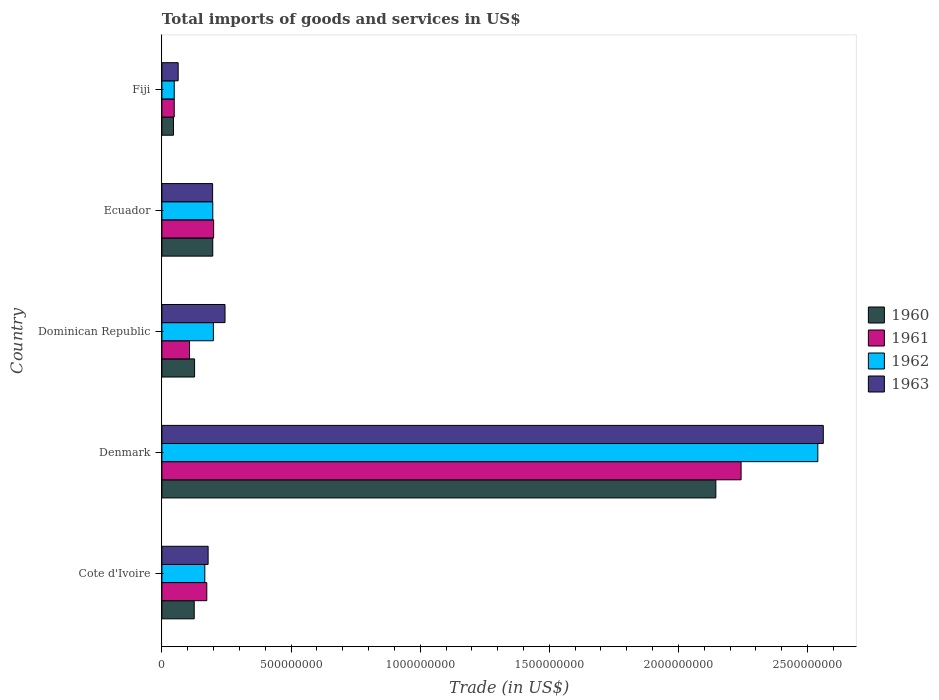How many groups of bars are there?
Provide a short and direct response. 5. Are the number of bars per tick equal to the number of legend labels?
Make the answer very short. Yes. What is the label of the 5th group of bars from the top?
Make the answer very short. Cote d'Ivoire. What is the total imports of goods and services in 1962 in Dominican Republic?
Keep it short and to the point. 1.99e+08. Across all countries, what is the maximum total imports of goods and services in 1962?
Offer a terse response. 2.54e+09. Across all countries, what is the minimum total imports of goods and services in 1962?
Make the answer very short. 4.77e+07. In which country was the total imports of goods and services in 1960 minimum?
Offer a very short reply. Fiji. What is the total total imports of goods and services in 1960 in the graph?
Offer a terse response. 2.64e+09. What is the difference between the total imports of goods and services in 1962 in Denmark and that in Ecuador?
Your answer should be compact. 2.34e+09. What is the difference between the total imports of goods and services in 1961 in Fiji and the total imports of goods and services in 1960 in Denmark?
Your answer should be very brief. -2.10e+09. What is the average total imports of goods and services in 1961 per country?
Offer a terse response. 5.54e+08. What is the difference between the total imports of goods and services in 1962 and total imports of goods and services in 1960 in Fiji?
Provide a succinct answer. 2.90e+06. In how many countries, is the total imports of goods and services in 1962 greater than 100000000 US$?
Ensure brevity in your answer.  4. What is the ratio of the total imports of goods and services in 1960 in Denmark to that in Ecuador?
Ensure brevity in your answer.  10.89. Is the total imports of goods and services in 1963 in Cote d'Ivoire less than that in Dominican Republic?
Your answer should be compact. Yes. Is the difference between the total imports of goods and services in 1962 in Dominican Republic and Fiji greater than the difference between the total imports of goods and services in 1960 in Dominican Republic and Fiji?
Make the answer very short. Yes. What is the difference between the highest and the second highest total imports of goods and services in 1960?
Provide a succinct answer. 1.95e+09. What is the difference between the highest and the lowest total imports of goods and services in 1960?
Your answer should be very brief. 2.10e+09. In how many countries, is the total imports of goods and services in 1962 greater than the average total imports of goods and services in 1962 taken over all countries?
Provide a succinct answer. 1. What does the 1st bar from the top in Ecuador represents?
Offer a terse response. 1963. What does the 4th bar from the bottom in Fiji represents?
Your answer should be very brief. 1963. Is it the case that in every country, the sum of the total imports of goods and services in 1960 and total imports of goods and services in 1961 is greater than the total imports of goods and services in 1962?
Your answer should be very brief. Yes. How many bars are there?
Keep it short and to the point. 20. Does the graph contain any zero values?
Ensure brevity in your answer.  No. What is the title of the graph?
Your response must be concise. Total imports of goods and services in US$. Does "1986" appear as one of the legend labels in the graph?
Ensure brevity in your answer.  No. What is the label or title of the X-axis?
Give a very brief answer. Trade (in US$). What is the Trade (in US$) of 1960 in Cote d'Ivoire?
Offer a terse response. 1.25e+08. What is the Trade (in US$) in 1961 in Cote d'Ivoire?
Make the answer very short. 1.74e+08. What is the Trade (in US$) in 1962 in Cote d'Ivoire?
Your response must be concise. 1.66e+08. What is the Trade (in US$) of 1963 in Cote d'Ivoire?
Give a very brief answer. 1.79e+08. What is the Trade (in US$) in 1960 in Denmark?
Give a very brief answer. 2.14e+09. What is the Trade (in US$) in 1961 in Denmark?
Ensure brevity in your answer.  2.24e+09. What is the Trade (in US$) in 1962 in Denmark?
Provide a succinct answer. 2.54e+09. What is the Trade (in US$) of 1963 in Denmark?
Offer a very short reply. 2.56e+09. What is the Trade (in US$) of 1960 in Dominican Republic?
Give a very brief answer. 1.26e+08. What is the Trade (in US$) of 1961 in Dominican Republic?
Ensure brevity in your answer.  1.07e+08. What is the Trade (in US$) in 1962 in Dominican Republic?
Your answer should be compact. 1.99e+08. What is the Trade (in US$) of 1963 in Dominican Republic?
Offer a terse response. 2.44e+08. What is the Trade (in US$) of 1960 in Ecuador?
Your response must be concise. 1.97e+08. What is the Trade (in US$) of 1961 in Ecuador?
Your response must be concise. 2.00e+08. What is the Trade (in US$) of 1962 in Ecuador?
Your response must be concise. 1.97e+08. What is the Trade (in US$) of 1963 in Ecuador?
Keep it short and to the point. 1.96e+08. What is the Trade (in US$) of 1960 in Fiji?
Offer a terse response. 4.48e+07. What is the Trade (in US$) in 1961 in Fiji?
Provide a short and direct response. 4.77e+07. What is the Trade (in US$) in 1962 in Fiji?
Your answer should be compact. 4.77e+07. What is the Trade (in US$) of 1963 in Fiji?
Ensure brevity in your answer.  6.30e+07. Across all countries, what is the maximum Trade (in US$) of 1960?
Provide a short and direct response. 2.14e+09. Across all countries, what is the maximum Trade (in US$) in 1961?
Keep it short and to the point. 2.24e+09. Across all countries, what is the maximum Trade (in US$) of 1962?
Ensure brevity in your answer.  2.54e+09. Across all countries, what is the maximum Trade (in US$) of 1963?
Keep it short and to the point. 2.56e+09. Across all countries, what is the minimum Trade (in US$) in 1960?
Ensure brevity in your answer.  4.48e+07. Across all countries, what is the minimum Trade (in US$) in 1961?
Ensure brevity in your answer.  4.77e+07. Across all countries, what is the minimum Trade (in US$) of 1962?
Ensure brevity in your answer.  4.77e+07. Across all countries, what is the minimum Trade (in US$) in 1963?
Provide a succinct answer. 6.30e+07. What is the total Trade (in US$) in 1960 in the graph?
Your response must be concise. 2.64e+09. What is the total Trade (in US$) in 1961 in the graph?
Your answer should be very brief. 2.77e+09. What is the total Trade (in US$) of 1962 in the graph?
Your response must be concise. 3.15e+09. What is the total Trade (in US$) of 1963 in the graph?
Your answer should be compact. 3.24e+09. What is the difference between the Trade (in US$) of 1960 in Cote d'Ivoire and that in Denmark?
Keep it short and to the point. -2.02e+09. What is the difference between the Trade (in US$) of 1961 in Cote d'Ivoire and that in Denmark?
Make the answer very short. -2.07e+09. What is the difference between the Trade (in US$) in 1962 in Cote d'Ivoire and that in Denmark?
Your answer should be compact. -2.37e+09. What is the difference between the Trade (in US$) of 1963 in Cote d'Ivoire and that in Denmark?
Your answer should be compact. -2.38e+09. What is the difference between the Trade (in US$) of 1960 in Cote d'Ivoire and that in Dominican Republic?
Offer a terse response. -1.39e+06. What is the difference between the Trade (in US$) in 1961 in Cote d'Ivoire and that in Dominican Republic?
Your answer should be compact. 6.68e+07. What is the difference between the Trade (in US$) in 1962 in Cote d'Ivoire and that in Dominican Republic?
Make the answer very short. -3.32e+07. What is the difference between the Trade (in US$) in 1963 in Cote d'Ivoire and that in Dominican Republic?
Offer a terse response. -6.54e+07. What is the difference between the Trade (in US$) of 1960 in Cote d'Ivoire and that in Ecuador?
Your response must be concise. -7.18e+07. What is the difference between the Trade (in US$) of 1961 in Cote d'Ivoire and that in Ecuador?
Give a very brief answer. -2.65e+07. What is the difference between the Trade (in US$) of 1962 in Cote d'Ivoire and that in Ecuador?
Give a very brief answer. -3.09e+07. What is the difference between the Trade (in US$) in 1963 in Cote d'Ivoire and that in Ecuador?
Keep it short and to the point. -1.74e+07. What is the difference between the Trade (in US$) of 1960 in Cote d'Ivoire and that in Fiji?
Your answer should be very brief. 8.03e+07. What is the difference between the Trade (in US$) in 1961 in Cote d'Ivoire and that in Fiji?
Keep it short and to the point. 1.26e+08. What is the difference between the Trade (in US$) of 1962 in Cote d'Ivoire and that in Fiji?
Provide a short and direct response. 1.18e+08. What is the difference between the Trade (in US$) of 1963 in Cote d'Ivoire and that in Fiji?
Keep it short and to the point. 1.16e+08. What is the difference between the Trade (in US$) in 1960 in Denmark and that in Dominican Republic?
Keep it short and to the point. 2.02e+09. What is the difference between the Trade (in US$) of 1961 in Denmark and that in Dominican Republic?
Offer a terse response. 2.14e+09. What is the difference between the Trade (in US$) of 1962 in Denmark and that in Dominican Republic?
Your answer should be compact. 2.34e+09. What is the difference between the Trade (in US$) of 1963 in Denmark and that in Dominican Republic?
Provide a succinct answer. 2.32e+09. What is the difference between the Trade (in US$) of 1960 in Denmark and that in Ecuador?
Give a very brief answer. 1.95e+09. What is the difference between the Trade (in US$) in 1961 in Denmark and that in Ecuador?
Give a very brief answer. 2.04e+09. What is the difference between the Trade (in US$) in 1962 in Denmark and that in Ecuador?
Your answer should be very brief. 2.34e+09. What is the difference between the Trade (in US$) of 1963 in Denmark and that in Ecuador?
Offer a terse response. 2.36e+09. What is the difference between the Trade (in US$) in 1960 in Denmark and that in Fiji?
Your answer should be very brief. 2.10e+09. What is the difference between the Trade (in US$) of 1961 in Denmark and that in Fiji?
Your answer should be compact. 2.19e+09. What is the difference between the Trade (in US$) in 1962 in Denmark and that in Fiji?
Provide a short and direct response. 2.49e+09. What is the difference between the Trade (in US$) in 1963 in Denmark and that in Fiji?
Offer a terse response. 2.50e+09. What is the difference between the Trade (in US$) of 1960 in Dominican Republic and that in Ecuador?
Provide a succinct answer. -7.04e+07. What is the difference between the Trade (in US$) of 1961 in Dominican Republic and that in Ecuador?
Provide a succinct answer. -9.34e+07. What is the difference between the Trade (in US$) of 1962 in Dominican Republic and that in Ecuador?
Make the answer very short. 2.27e+06. What is the difference between the Trade (in US$) in 1963 in Dominican Republic and that in Ecuador?
Your answer should be compact. 4.80e+07. What is the difference between the Trade (in US$) in 1960 in Dominican Republic and that in Fiji?
Offer a terse response. 8.17e+07. What is the difference between the Trade (in US$) in 1961 in Dominican Republic and that in Fiji?
Provide a short and direct response. 5.92e+07. What is the difference between the Trade (in US$) of 1962 in Dominican Republic and that in Fiji?
Your answer should be very brief. 1.52e+08. What is the difference between the Trade (in US$) of 1963 in Dominican Republic and that in Fiji?
Your answer should be very brief. 1.81e+08. What is the difference between the Trade (in US$) of 1960 in Ecuador and that in Fiji?
Ensure brevity in your answer.  1.52e+08. What is the difference between the Trade (in US$) of 1961 in Ecuador and that in Fiji?
Offer a terse response. 1.53e+08. What is the difference between the Trade (in US$) of 1962 in Ecuador and that in Fiji?
Ensure brevity in your answer.  1.49e+08. What is the difference between the Trade (in US$) of 1963 in Ecuador and that in Fiji?
Offer a very short reply. 1.33e+08. What is the difference between the Trade (in US$) in 1960 in Cote d'Ivoire and the Trade (in US$) in 1961 in Denmark?
Your response must be concise. -2.12e+09. What is the difference between the Trade (in US$) in 1960 in Cote d'Ivoire and the Trade (in US$) in 1962 in Denmark?
Your response must be concise. -2.41e+09. What is the difference between the Trade (in US$) in 1960 in Cote d'Ivoire and the Trade (in US$) in 1963 in Denmark?
Provide a short and direct response. -2.44e+09. What is the difference between the Trade (in US$) in 1961 in Cote d'Ivoire and the Trade (in US$) in 1962 in Denmark?
Your answer should be very brief. -2.37e+09. What is the difference between the Trade (in US$) in 1961 in Cote d'Ivoire and the Trade (in US$) in 1963 in Denmark?
Offer a very short reply. -2.39e+09. What is the difference between the Trade (in US$) in 1962 in Cote d'Ivoire and the Trade (in US$) in 1963 in Denmark?
Provide a succinct answer. -2.39e+09. What is the difference between the Trade (in US$) in 1960 in Cote d'Ivoire and the Trade (in US$) in 1961 in Dominican Republic?
Provide a succinct answer. 1.82e+07. What is the difference between the Trade (in US$) in 1960 in Cote d'Ivoire and the Trade (in US$) in 1962 in Dominican Republic?
Keep it short and to the point. -7.42e+07. What is the difference between the Trade (in US$) of 1960 in Cote d'Ivoire and the Trade (in US$) of 1963 in Dominican Republic?
Provide a succinct answer. -1.19e+08. What is the difference between the Trade (in US$) in 1961 in Cote d'Ivoire and the Trade (in US$) in 1962 in Dominican Republic?
Your answer should be compact. -2.56e+07. What is the difference between the Trade (in US$) of 1961 in Cote d'Ivoire and the Trade (in US$) of 1963 in Dominican Republic?
Ensure brevity in your answer.  -7.07e+07. What is the difference between the Trade (in US$) in 1962 in Cote d'Ivoire and the Trade (in US$) in 1963 in Dominican Republic?
Ensure brevity in your answer.  -7.83e+07. What is the difference between the Trade (in US$) in 1960 in Cote d'Ivoire and the Trade (in US$) in 1961 in Ecuador?
Make the answer very short. -7.52e+07. What is the difference between the Trade (in US$) of 1960 in Cote d'Ivoire and the Trade (in US$) of 1962 in Ecuador?
Ensure brevity in your answer.  -7.19e+07. What is the difference between the Trade (in US$) of 1960 in Cote d'Ivoire and the Trade (in US$) of 1963 in Ecuador?
Give a very brief answer. -7.13e+07. What is the difference between the Trade (in US$) of 1961 in Cote d'Ivoire and the Trade (in US$) of 1962 in Ecuador?
Keep it short and to the point. -2.33e+07. What is the difference between the Trade (in US$) in 1961 in Cote d'Ivoire and the Trade (in US$) in 1963 in Ecuador?
Offer a terse response. -2.26e+07. What is the difference between the Trade (in US$) of 1962 in Cote d'Ivoire and the Trade (in US$) of 1963 in Ecuador?
Ensure brevity in your answer.  -3.02e+07. What is the difference between the Trade (in US$) of 1960 in Cote d'Ivoire and the Trade (in US$) of 1961 in Fiji?
Provide a succinct answer. 7.74e+07. What is the difference between the Trade (in US$) of 1960 in Cote d'Ivoire and the Trade (in US$) of 1962 in Fiji?
Keep it short and to the point. 7.74e+07. What is the difference between the Trade (in US$) of 1960 in Cote d'Ivoire and the Trade (in US$) of 1963 in Fiji?
Ensure brevity in your answer.  6.21e+07. What is the difference between the Trade (in US$) in 1961 in Cote d'Ivoire and the Trade (in US$) in 1962 in Fiji?
Keep it short and to the point. 1.26e+08. What is the difference between the Trade (in US$) of 1961 in Cote d'Ivoire and the Trade (in US$) of 1963 in Fiji?
Your answer should be very brief. 1.11e+08. What is the difference between the Trade (in US$) in 1962 in Cote d'Ivoire and the Trade (in US$) in 1963 in Fiji?
Offer a terse response. 1.03e+08. What is the difference between the Trade (in US$) of 1960 in Denmark and the Trade (in US$) of 1961 in Dominican Republic?
Offer a terse response. 2.04e+09. What is the difference between the Trade (in US$) in 1960 in Denmark and the Trade (in US$) in 1962 in Dominican Republic?
Provide a succinct answer. 1.95e+09. What is the difference between the Trade (in US$) in 1960 in Denmark and the Trade (in US$) in 1963 in Dominican Republic?
Your answer should be compact. 1.90e+09. What is the difference between the Trade (in US$) in 1961 in Denmark and the Trade (in US$) in 1962 in Dominican Republic?
Your answer should be very brief. 2.04e+09. What is the difference between the Trade (in US$) in 1961 in Denmark and the Trade (in US$) in 1963 in Dominican Republic?
Provide a short and direct response. 2.00e+09. What is the difference between the Trade (in US$) of 1962 in Denmark and the Trade (in US$) of 1963 in Dominican Republic?
Offer a terse response. 2.30e+09. What is the difference between the Trade (in US$) of 1960 in Denmark and the Trade (in US$) of 1961 in Ecuador?
Your answer should be compact. 1.94e+09. What is the difference between the Trade (in US$) of 1960 in Denmark and the Trade (in US$) of 1962 in Ecuador?
Your answer should be very brief. 1.95e+09. What is the difference between the Trade (in US$) of 1960 in Denmark and the Trade (in US$) of 1963 in Ecuador?
Keep it short and to the point. 1.95e+09. What is the difference between the Trade (in US$) in 1961 in Denmark and the Trade (in US$) in 1962 in Ecuador?
Provide a succinct answer. 2.05e+09. What is the difference between the Trade (in US$) in 1961 in Denmark and the Trade (in US$) in 1963 in Ecuador?
Make the answer very short. 2.05e+09. What is the difference between the Trade (in US$) of 1962 in Denmark and the Trade (in US$) of 1963 in Ecuador?
Ensure brevity in your answer.  2.34e+09. What is the difference between the Trade (in US$) of 1960 in Denmark and the Trade (in US$) of 1961 in Fiji?
Give a very brief answer. 2.10e+09. What is the difference between the Trade (in US$) in 1960 in Denmark and the Trade (in US$) in 1962 in Fiji?
Give a very brief answer. 2.10e+09. What is the difference between the Trade (in US$) in 1960 in Denmark and the Trade (in US$) in 1963 in Fiji?
Make the answer very short. 2.08e+09. What is the difference between the Trade (in US$) of 1961 in Denmark and the Trade (in US$) of 1962 in Fiji?
Your response must be concise. 2.19e+09. What is the difference between the Trade (in US$) in 1961 in Denmark and the Trade (in US$) in 1963 in Fiji?
Your response must be concise. 2.18e+09. What is the difference between the Trade (in US$) in 1962 in Denmark and the Trade (in US$) in 1963 in Fiji?
Give a very brief answer. 2.48e+09. What is the difference between the Trade (in US$) in 1960 in Dominican Republic and the Trade (in US$) in 1961 in Ecuador?
Your answer should be compact. -7.38e+07. What is the difference between the Trade (in US$) in 1960 in Dominican Republic and the Trade (in US$) in 1962 in Ecuador?
Your answer should be very brief. -7.05e+07. What is the difference between the Trade (in US$) in 1960 in Dominican Republic and the Trade (in US$) in 1963 in Ecuador?
Make the answer very short. -6.99e+07. What is the difference between the Trade (in US$) of 1961 in Dominican Republic and the Trade (in US$) of 1962 in Ecuador?
Your response must be concise. -9.01e+07. What is the difference between the Trade (in US$) in 1961 in Dominican Republic and the Trade (in US$) in 1963 in Ecuador?
Give a very brief answer. -8.95e+07. What is the difference between the Trade (in US$) of 1962 in Dominican Republic and the Trade (in US$) of 1963 in Ecuador?
Ensure brevity in your answer.  2.94e+06. What is the difference between the Trade (in US$) in 1960 in Dominican Republic and the Trade (in US$) in 1961 in Fiji?
Ensure brevity in your answer.  7.88e+07. What is the difference between the Trade (in US$) in 1960 in Dominican Republic and the Trade (in US$) in 1962 in Fiji?
Keep it short and to the point. 7.88e+07. What is the difference between the Trade (in US$) of 1960 in Dominican Republic and the Trade (in US$) of 1963 in Fiji?
Your answer should be compact. 6.35e+07. What is the difference between the Trade (in US$) of 1961 in Dominican Republic and the Trade (in US$) of 1962 in Fiji?
Your response must be concise. 5.92e+07. What is the difference between the Trade (in US$) of 1961 in Dominican Republic and the Trade (in US$) of 1963 in Fiji?
Offer a terse response. 4.39e+07. What is the difference between the Trade (in US$) of 1962 in Dominican Republic and the Trade (in US$) of 1963 in Fiji?
Ensure brevity in your answer.  1.36e+08. What is the difference between the Trade (in US$) of 1960 in Ecuador and the Trade (in US$) of 1961 in Fiji?
Provide a short and direct response. 1.49e+08. What is the difference between the Trade (in US$) of 1960 in Ecuador and the Trade (in US$) of 1962 in Fiji?
Make the answer very short. 1.49e+08. What is the difference between the Trade (in US$) of 1960 in Ecuador and the Trade (in US$) of 1963 in Fiji?
Keep it short and to the point. 1.34e+08. What is the difference between the Trade (in US$) in 1961 in Ecuador and the Trade (in US$) in 1962 in Fiji?
Keep it short and to the point. 1.53e+08. What is the difference between the Trade (in US$) in 1961 in Ecuador and the Trade (in US$) in 1963 in Fiji?
Keep it short and to the point. 1.37e+08. What is the difference between the Trade (in US$) in 1962 in Ecuador and the Trade (in US$) in 1963 in Fiji?
Offer a terse response. 1.34e+08. What is the average Trade (in US$) in 1960 per country?
Provide a short and direct response. 5.28e+08. What is the average Trade (in US$) of 1961 per country?
Ensure brevity in your answer.  5.54e+08. What is the average Trade (in US$) of 1962 per country?
Your response must be concise. 6.30e+08. What is the average Trade (in US$) of 1963 per country?
Your answer should be compact. 6.49e+08. What is the difference between the Trade (in US$) in 1960 and Trade (in US$) in 1961 in Cote d'Ivoire?
Your answer should be very brief. -4.86e+07. What is the difference between the Trade (in US$) of 1960 and Trade (in US$) of 1962 in Cote d'Ivoire?
Give a very brief answer. -4.10e+07. What is the difference between the Trade (in US$) in 1960 and Trade (in US$) in 1963 in Cote d'Ivoire?
Make the answer very short. -5.39e+07. What is the difference between the Trade (in US$) in 1961 and Trade (in US$) in 1962 in Cote d'Ivoire?
Keep it short and to the point. 7.61e+06. What is the difference between the Trade (in US$) of 1961 and Trade (in US$) of 1963 in Cote d'Ivoire?
Provide a succinct answer. -5.25e+06. What is the difference between the Trade (in US$) of 1962 and Trade (in US$) of 1963 in Cote d'Ivoire?
Give a very brief answer. -1.29e+07. What is the difference between the Trade (in US$) in 1960 and Trade (in US$) in 1961 in Denmark?
Ensure brevity in your answer.  -9.78e+07. What is the difference between the Trade (in US$) in 1960 and Trade (in US$) in 1962 in Denmark?
Offer a very short reply. -3.95e+08. What is the difference between the Trade (in US$) of 1960 and Trade (in US$) of 1963 in Denmark?
Keep it short and to the point. -4.16e+08. What is the difference between the Trade (in US$) in 1961 and Trade (in US$) in 1962 in Denmark?
Your response must be concise. -2.97e+08. What is the difference between the Trade (in US$) of 1961 and Trade (in US$) of 1963 in Denmark?
Make the answer very short. -3.18e+08. What is the difference between the Trade (in US$) of 1962 and Trade (in US$) of 1963 in Denmark?
Your answer should be very brief. -2.12e+07. What is the difference between the Trade (in US$) of 1960 and Trade (in US$) of 1961 in Dominican Republic?
Keep it short and to the point. 1.96e+07. What is the difference between the Trade (in US$) in 1960 and Trade (in US$) in 1962 in Dominican Republic?
Keep it short and to the point. -7.28e+07. What is the difference between the Trade (in US$) of 1960 and Trade (in US$) of 1963 in Dominican Republic?
Provide a succinct answer. -1.18e+08. What is the difference between the Trade (in US$) in 1961 and Trade (in US$) in 1962 in Dominican Republic?
Your answer should be very brief. -9.24e+07. What is the difference between the Trade (in US$) in 1961 and Trade (in US$) in 1963 in Dominican Republic?
Offer a terse response. -1.38e+08. What is the difference between the Trade (in US$) in 1962 and Trade (in US$) in 1963 in Dominican Republic?
Provide a succinct answer. -4.51e+07. What is the difference between the Trade (in US$) in 1960 and Trade (in US$) in 1961 in Ecuador?
Your answer should be compact. -3.37e+06. What is the difference between the Trade (in US$) of 1960 and Trade (in US$) of 1962 in Ecuador?
Offer a very short reply. -1.34e+05. What is the difference between the Trade (in US$) in 1960 and Trade (in US$) in 1963 in Ecuador?
Offer a terse response. 5.38e+05. What is the difference between the Trade (in US$) in 1961 and Trade (in US$) in 1962 in Ecuador?
Offer a very short reply. 3.24e+06. What is the difference between the Trade (in US$) in 1961 and Trade (in US$) in 1963 in Ecuador?
Make the answer very short. 3.91e+06. What is the difference between the Trade (in US$) of 1962 and Trade (in US$) of 1963 in Ecuador?
Keep it short and to the point. 6.72e+05. What is the difference between the Trade (in US$) of 1960 and Trade (in US$) of 1961 in Fiji?
Your answer should be compact. -2.90e+06. What is the difference between the Trade (in US$) in 1960 and Trade (in US$) in 1962 in Fiji?
Your answer should be very brief. -2.90e+06. What is the difference between the Trade (in US$) of 1960 and Trade (in US$) of 1963 in Fiji?
Offer a very short reply. -1.81e+07. What is the difference between the Trade (in US$) of 1961 and Trade (in US$) of 1962 in Fiji?
Give a very brief answer. 0. What is the difference between the Trade (in US$) of 1961 and Trade (in US$) of 1963 in Fiji?
Your answer should be compact. -1.52e+07. What is the difference between the Trade (in US$) in 1962 and Trade (in US$) in 1963 in Fiji?
Provide a succinct answer. -1.52e+07. What is the ratio of the Trade (in US$) of 1960 in Cote d'Ivoire to that in Denmark?
Your answer should be compact. 0.06. What is the ratio of the Trade (in US$) of 1961 in Cote d'Ivoire to that in Denmark?
Your answer should be compact. 0.08. What is the ratio of the Trade (in US$) of 1962 in Cote d'Ivoire to that in Denmark?
Ensure brevity in your answer.  0.07. What is the ratio of the Trade (in US$) of 1963 in Cote d'Ivoire to that in Denmark?
Your response must be concise. 0.07. What is the ratio of the Trade (in US$) of 1960 in Cote d'Ivoire to that in Dominican Republic?
Offer a terse response. 0.99. What is the ratio of the Trade (in US$) in 1961 in Cote d'Ivoire to that in Dominican Republic?
Offer a very short reply. 1.63. What is the ratio of the Trade (in US$) of 1962 in Cote d'Ivoire to that in Dominican Republic?
Ensure brevity in your answer.  0.83. What is the ratio of the Trade (in US$) in 1963 in Cote d'Ivoire to that in Dominican Republic?
Offer a very short reply. 0.73. What is the ratio of the Trade (in US$) in 1960 in Cote d'Ivoire to that in Ecuador?
Your answer should be very brief. 0.64. What is the ratio of the Trade (in US$) of 1961 in Cote d'Ivoire to that in Ecuador?
Give a very brief answer. 0.87. What is the ratio of the Trade (in US$) of 1962 in Cote d'Ivoire to that in Ecuador?
Your response must be concise. 0.84. What is the ratio of the Trade (in US$) in 1963 in Cote d'Ivoire to that in Ecuador?
Your response must be concise. 0.91. What is the ratio of the Trade (in US$) in 1960 in Cote d'Ivoire to that in Fiji?
Offer a very short reply. 2.79. What is the ratio of the Trade (in US$) of 1961 in Cote d'Ivoire to that in Fiji?
Make the answer very short. 3.64. What is the ratio of the Trade (in US$) of 1962 in Cote d'Ivoire to that in Fiji?
Keep it short and to the point. 3.48. What is the ratio of the Trade (in US$) of 1963 in Cote d'Ivoire to that in Fiji?
Keep it short and to the point. 2.84. What is the ratio of the Trade (in US$) of 1960 in Denmark to that in Dominican Republic?
Your answer should be compact. 16.95. What is the ratio of the Trade (in US$) of 1961 in Denmark to that in Dominican Republic?
Provide a short and direct response. 20.98. What is the ratio of the Trade (in US$) in 1962 in Denmark to that in Dominican Republic?
Give a very brief answer. 12.74. What is the ratio of the Trade (in US$) in 1963 in Denmark to that in Dominican Republic?
Offer a very short reply. 10.48. What is the ratio of the Trade (in US$) in 1960 in Denmark to that in Ecuador?
Offer a terse response. 10.89. What is the ratio of the Trade (in US$) of 1961 in Denmark to that in Ecuador?
Ensure brevity in your answer.  11.2. What is the ratio of the Trade (in US$) of 1962 in Denmark to that in Ecuador?
Your answer should be very brief. 12.89. What is the ratio of the Trade (in US$) of 1963 in Denmark to that in Ecuador?
Provide a short and direct response. 13.04. What is the ratio of the Trade (in US$) in 1960 in Denmark to that in Fiji?
Ensure brevity in your answer.  47.84. What is the ratio of the Trade (in US$) in 1961 in Denmark to that in Fiji?
Ensure brevity in your answer.  46.98. What is the ratio of the Trade (in US$) of 1962 in Denmark to that in Fiji?
Your answer should be very brief. 53.21. What is the ratio of the Trade (in US$) in 1963 in Denmark to that in Fiji?
Your response must be concise. 40.67. What is the ratio of the Trade (in US$) of 1960 in Dominican Republic to that in Ecuador?
Your response must be concise. 0.64. What is the ratio of the Trade (in US$) in 1961 in Dominican Republic to that in Ecuador?
Offer a very short reply. 0.53. What is the ratio of the Trade (in US$) of 1962 in Dominican Republic to that in Ecuador?
Make the answer very short. 1.01. What is the ratio of the Trade (in US$) in 1963 in Dominican Republic to that in Ecuador?
Give a very brief answer. 1.24. What is the ratio of the Trade (in US$) of 1960 in Dominican Republic to that in Fiji?
Your response must be concise. 2.82. What is the ratio of the Trade (in US$) of 1961 in Dominican Republic to that in Fiji?
Your response must be concise. 2.24. What is the ratio of the Trade (in US$) in 1962 in Dominican Republic to that in Fiji?
Keep it short and to the point. 4.18. What is the ratio of the Trade (in US$) of 1963 in Dominican Republic to that in Fiji?
Offer a very short reply. 3.88. What is the ratio of the Trade (in US$) in 1960 in Ecuador to that in Fiji?
Provide a succinct answer. 4.39. What is the ratio of the Trade (in US$) in 1961 in Ecuador to that in Fiji?
Your answer should be compact. 4.2. What is the ratio of the Trade (in US$) in 1962 in Ecuador to that in Fiji?
Offer a terse response. 4.13. What is the ratio of the Trade (in US$) of 1963 in Ecuador to that in Fiji?
Ensure brevity in your answer.  3.12. What is the difference between the highest and the second highest Trade (in US$) of 1960?
Your answer should be compact. 1.95e+09. What is the difference between the highest and the second highest Trade (in US$) of 1961?
Provide a short and direct response. 2.04e+09. What is the difference between the highest and the second highest Trade (in US$) of 1962?
Offer a terse response. 2.34e+09. What is the difference between the highest and the second highest Trade (in US$) of 1963?
Give a very brief answer. 2.32e+09. What is the difference between the highest and the lowest Trade (in US$) in 1960?
Offer a terse response. 2.10e+09. What is the difference between the highest and the lowest Trade (in US$) in 1961?
Offer a very short reply. 2.19e+09. What is the difference between the highest and the lowest Trade (in US$) in 1962?
Make the answer very short. 2.49e+09. What is the difference between the highest and the lowest Trade (in US$) of 1963?
Give a very brief answer. 2.50e+09. 